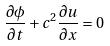Convert formula to latex. <formula><loc_0><loc_0><loc_500><loc_500>\frac { \partial \phi } { \partial t } + c ^ { 2 } \frac { \partial u } { \partial x } = 0</formula> 